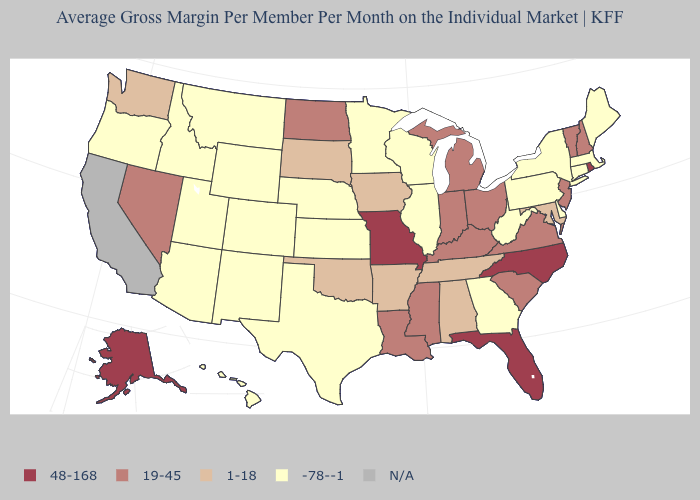Among the states that border Utah , which have the lowest value?
Concise answer only. Arizona, Colorado, Idaho, New Mexico, Wyoming. Name the states that have a value in the range N/A?
Keep it brief. California. What is the value of Arizona?
Be succinct. -78--1. What is the value of Missouri?
Concise answer only. 48-168. Name the states that have a value in the range -78--1?
Concise answer only. Arizona, Colorado, Connecticut, Delaware, Georgia, Hawaii, Idaho, Illinois, Kansas, Maine, Massachusetts, Minnesota, Montana, Nebraska, New Mexico, New York, Oregon, Pennsylvania, Texas, Utah, West Virginia, Wisconsin, Wyoming. What is the value of Montana?
Short answer required. -78--1. Does the map have missing data?
Short answer required. Yes. What is the lowest value in the Northeast?
Write a very short answer. -78--1. Name the states that have a value in the range -78--1?
Be succinct. Arizona, Colorado, Connecticut, Delaware, Georgia, Hawaii, Idaho, Illinois, Kansas, Maine, Massachusetts, Minnesota, Montana, Nebraska, New Mexico, New York, Oregon, Pennsylvania, Texas, Utah, West Virginia, Wisconsin, Wyoming. Name the states that have a value in the range N/A?
Give a very brief answer. California. What is the lowest value in states that border South Carolina?
Answer briefly. -78--1. Among the states that border Kansas , which have the lowest value?
Concise answer only. Colorado, Nebraska. What is the lowest value in the USA?
Keep it brief. -78--1. Does Texas have the lowest value in the South?
Be succinct. Yes. 